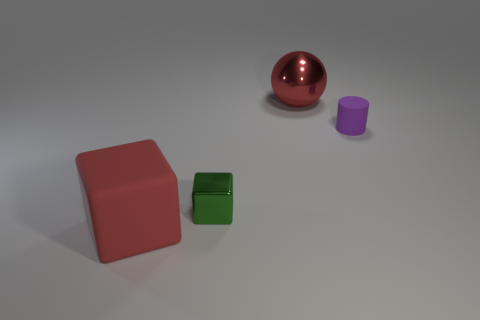How big is the metallic cube?
Your answer should be compact. Small. There is a matte object that is right of the green metallic block; what size is it?
Provide a succinct answer. Small. Do the large ball and the matte cube have the same color?
Offer a very short reply. Yes. What number of red rubber objects are the same shape as the big metallic object?
Your answer should be compact. 0. What material is the small purple cylinder?
Offer a very short reply. Rubber. Are there an equal number of green metallic cubes that are right of the tiny purple rubber cylinder and small brown matte spheres?
Provide a succinct answer. Yes. The rubber thing that is the same size as the green metal block is what shape?
Make the answer very short. Cylinder. Is there a tiny cylinder on the right side of the big thing right of the small metallic object?
Give a very brief answer. Yes. What number of tiny things are either matte blocks or blue metallic cylinders?
Your answer should be compact. 0. Are there any other red metallic spheres that have the same size as the metallic sphere?
Your response must be concise. No. 